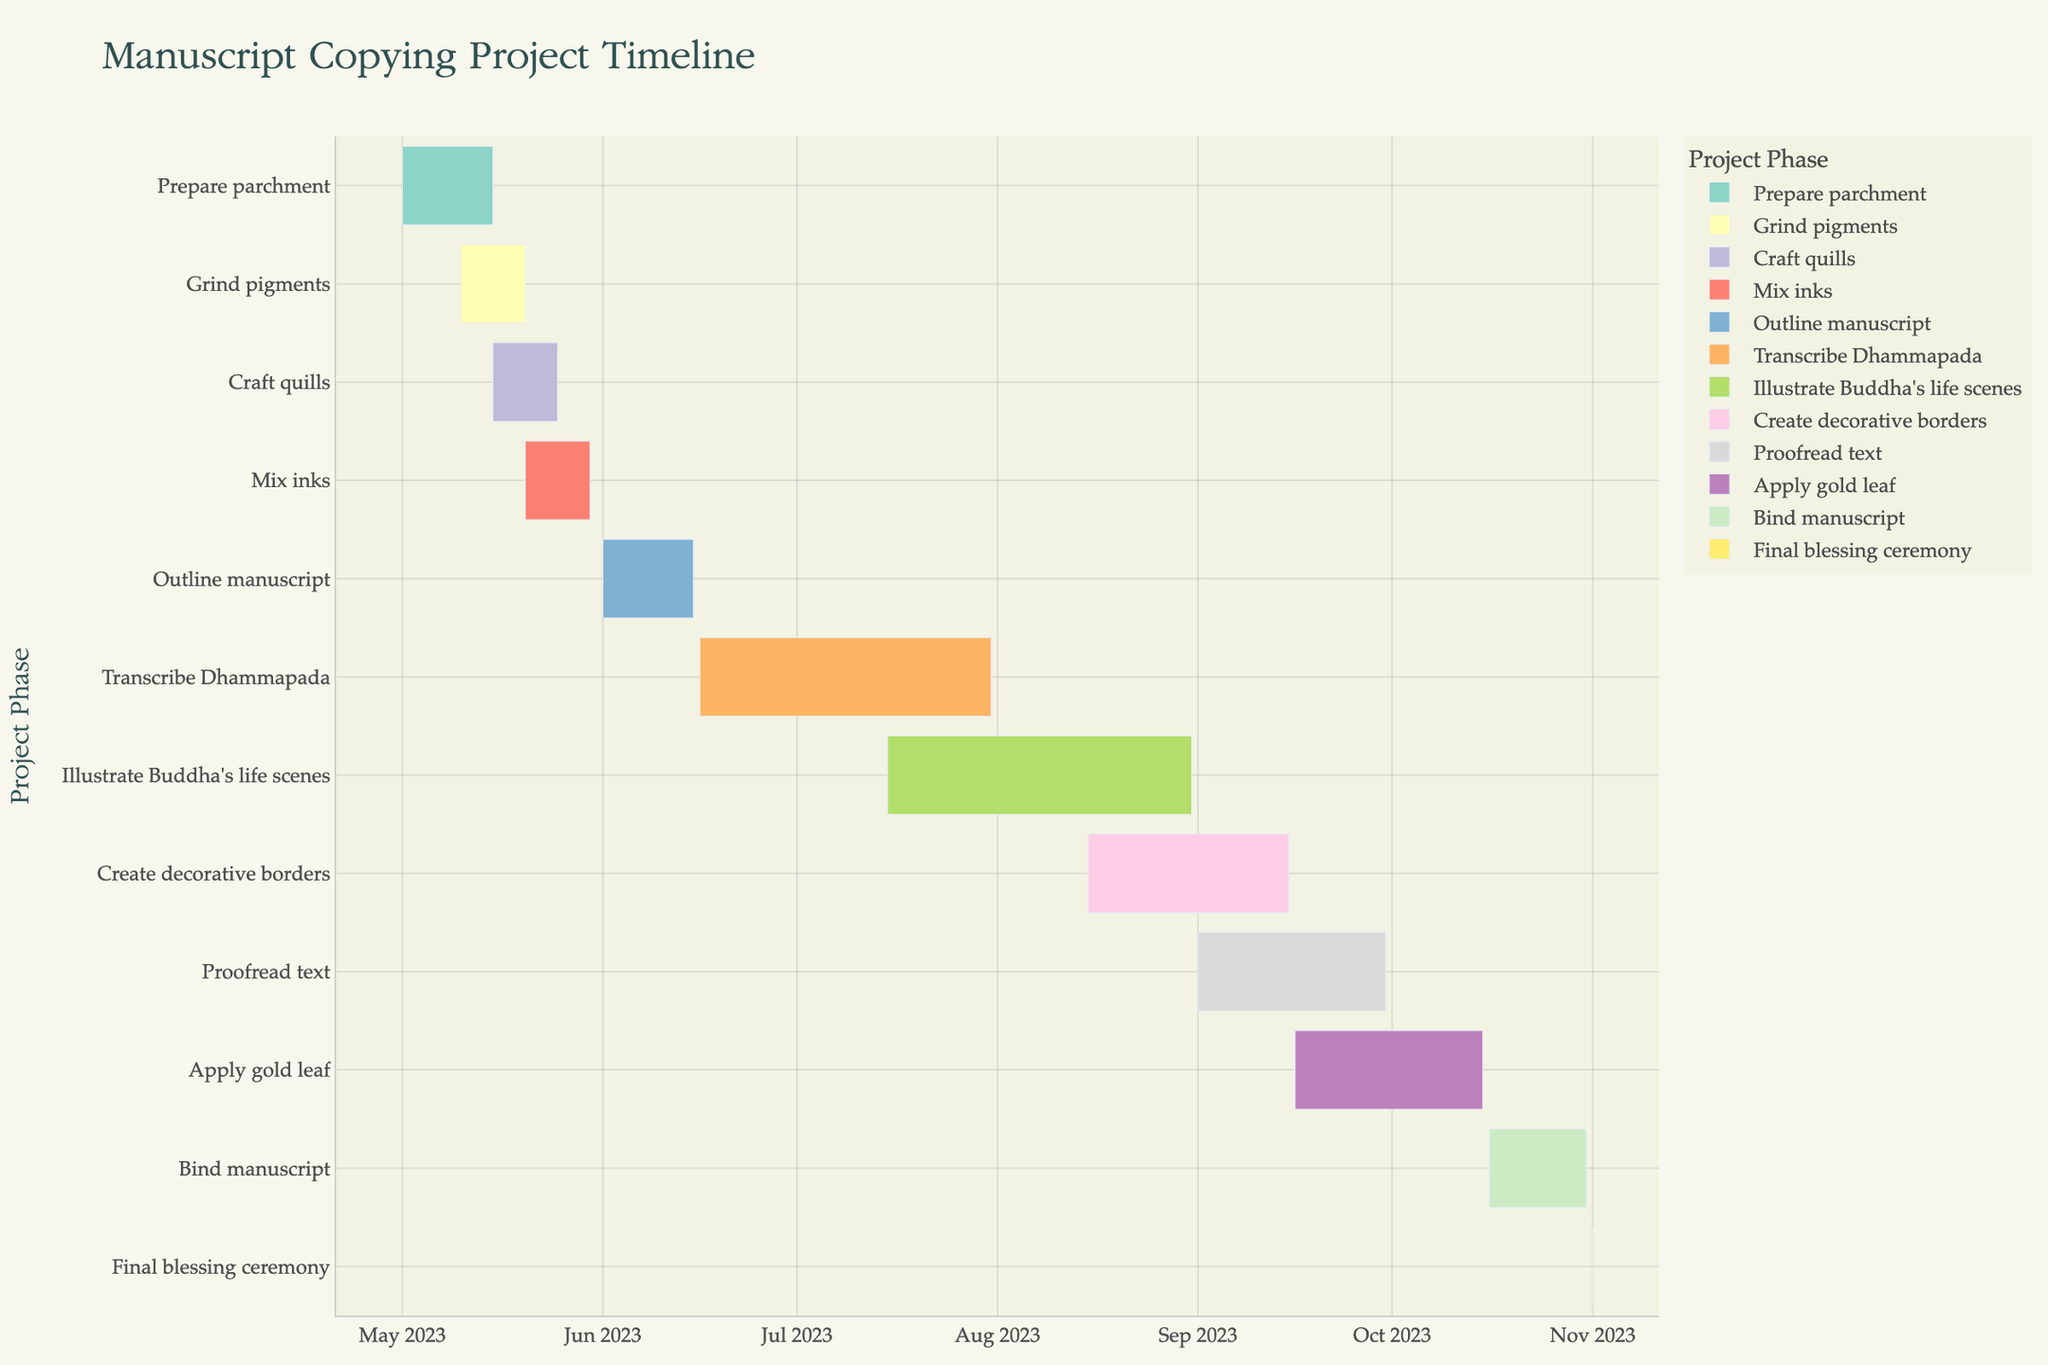What is the title of the Gantt Chart? The title of the Gantt Chart is usually located at the top of the chart. By examining this area, you can determine the given title.
Answer: "Manuscript Copying Project Timeline" Which task has the shortest duration? The Final blessing ceremony appears to only last for one day, making it the shortest duration task in the Gantt Chart.
Answer: "Final blessing ceremony" When does the task of Grinding pigments begin and end? To determine the start and end dates, locate the "Grind pigments" task on the y-axis and read off the corresponding dates from the x-axis.
Answer: Start: 2023-05-10, End: 2023-05-20 How many tasks are in the Writing phase? The Writing phase includes tasks related to the transcription and outline of the manuscript. Count the tasks under this category: Outline manuscript and Transcribe Dhammapada.
Answer: 2 tasks During which dates are both Grinding pigments and Crafting quills being conducted? Grind pigments starts on 2023-05-10 and ends on 2023-05-20; Craft quills starts on 2023-05-15 and ends on 2023-05-25. The overlapping period is from 2023-05-15 to 2023-05-20.
Answer: May 15 to May 20, 2023 Which tasks are conducted in the month of July 2023? Review the tasks and their timelines to identify any tasks that are ongoing in July 2023. Transcribe Dhammapada and Illustrate Buddha's life scenes are documented as ongoing during this month.
Answer: "Transcribe Dhammapada" and "Illustrate Buddha's life scenes" What is the difference in duration between Creating decorative borders and Applying gold leaf? Calculate the duration for each task: Creating decorative borders (2023-08-15 to 2023-09-15) = 31 days; Applying gold leaf (2023-09-16 to 2023-10-15) = 30 days. Subtract the durations.
Answer: 1 day Which tasks overlap with the Illustration phase? The Illustration phase includes Illustrate Buddha's life scenes and tasks overlapping with this from the chart such as Transcribe Dhammapada and Create decorative borders.
Answer: "Transcribe Dhammapada", "Create decorative borders" What is the total duration of the entire project? Calculate the overall duration by considering the span from the earliest starting task (Prepare parchment, 2023-05-01) to the last ending task (Final blessing ceremony, 2023-11-01).
Answer: 185 days Which task directly follows the Mixing inks phase? Identify the task that starts immediately after the end date of Mixing inks (2023-05-30).
Answer: "Outline manuscript" is the next task starting on 2023-06-01 